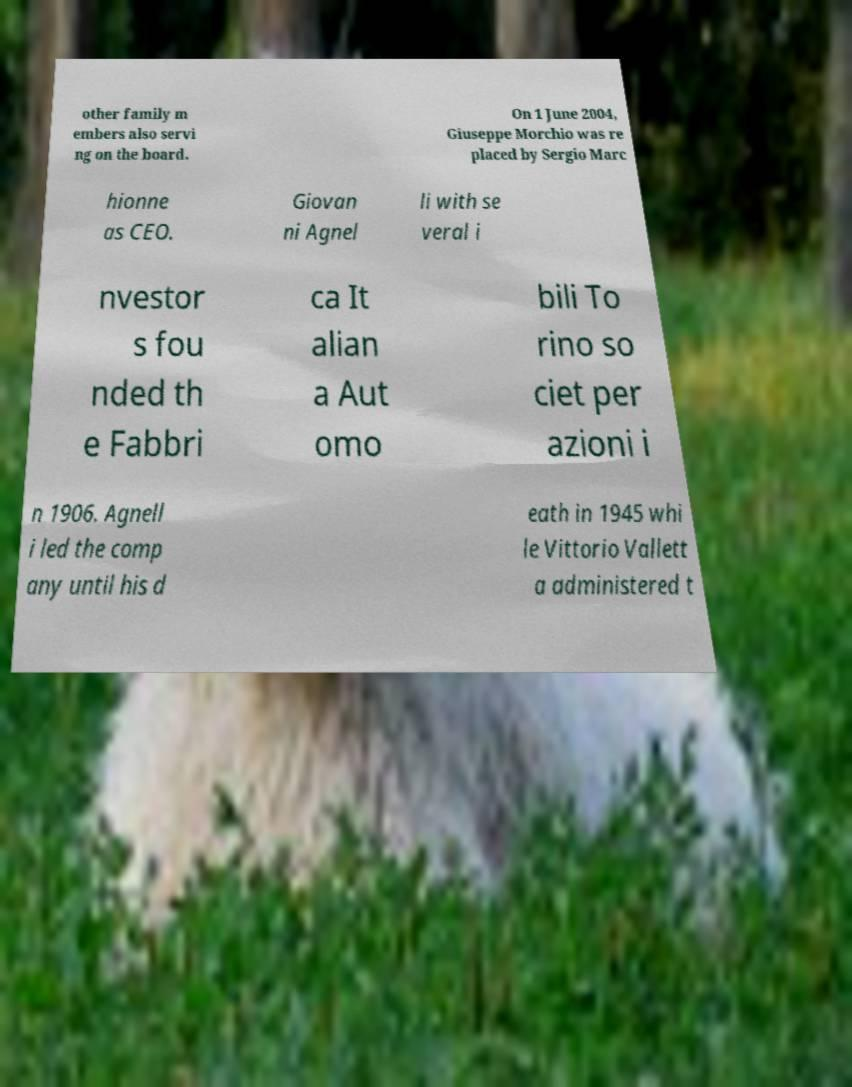I need the written content from this picture converted into text. Can you do that? other family m embers also servi ng on the board. On 1 June 2004, Giuseppe Morchio was re placed by Sergio Marc hionne as CEO. Giovan ni Agnel li with se veral i nvestor s fou nded th e Fabbri ca It alian a Aut omo bili To rino so ciet per azioni i n 1906. Agnell i led the comp any until his d eath in 1945 whi le Vittorio Vallett a administered t 